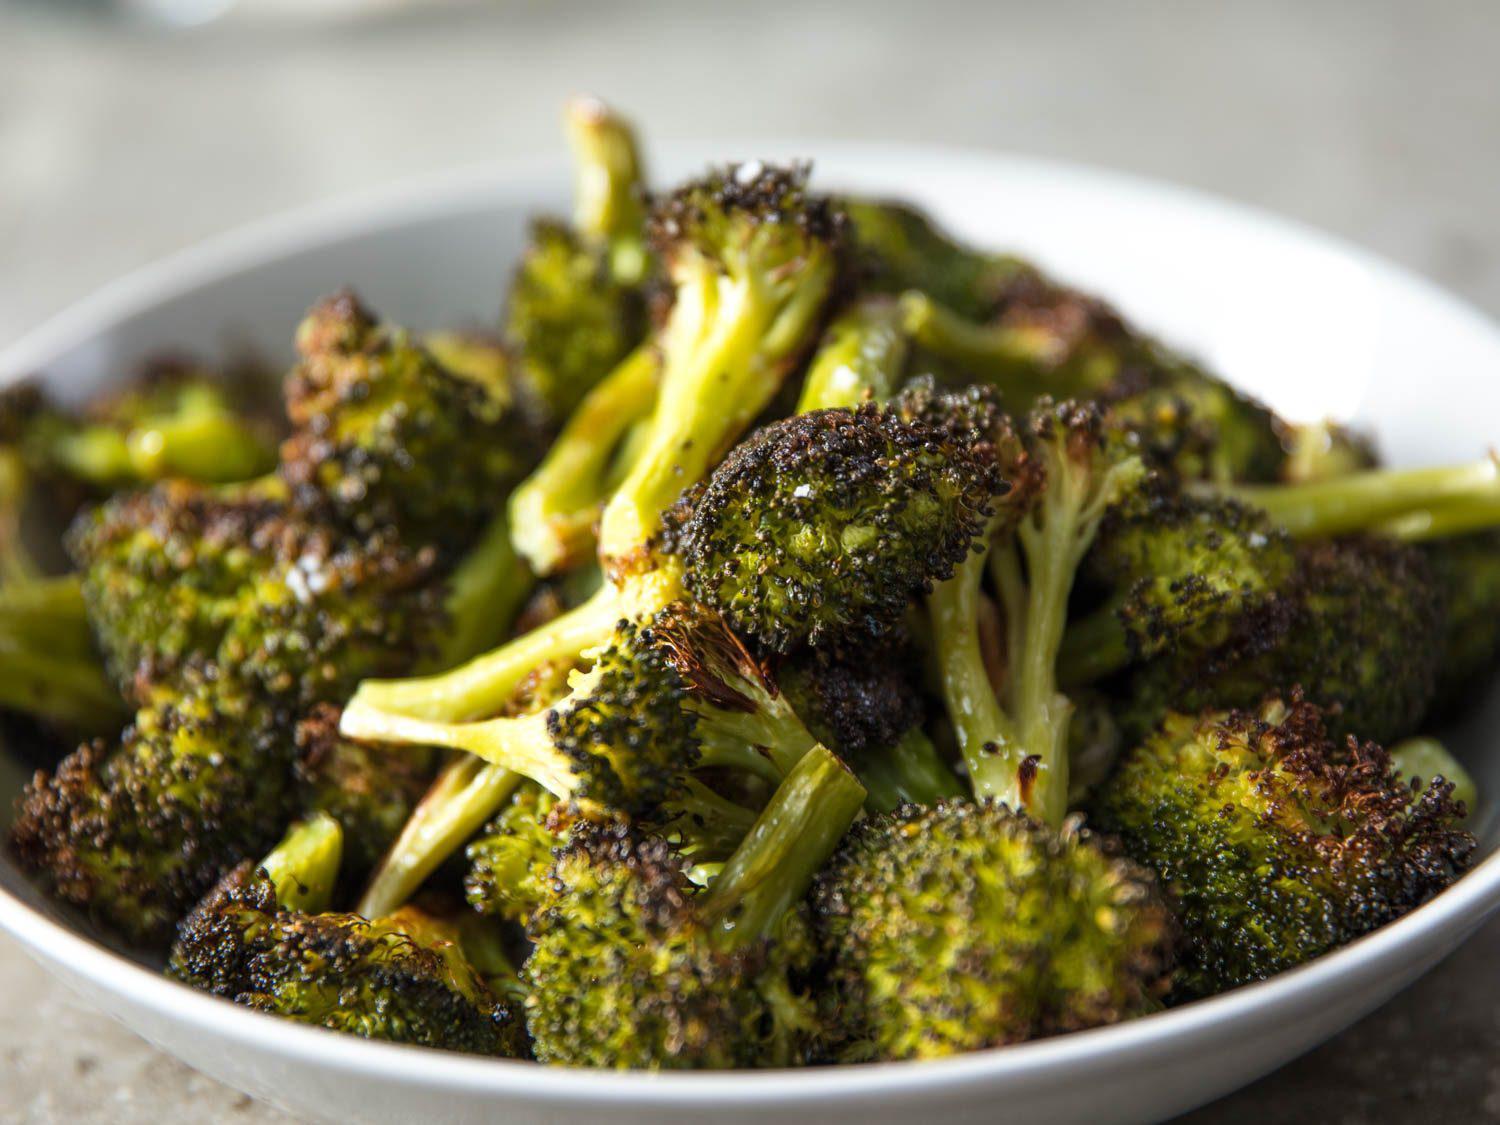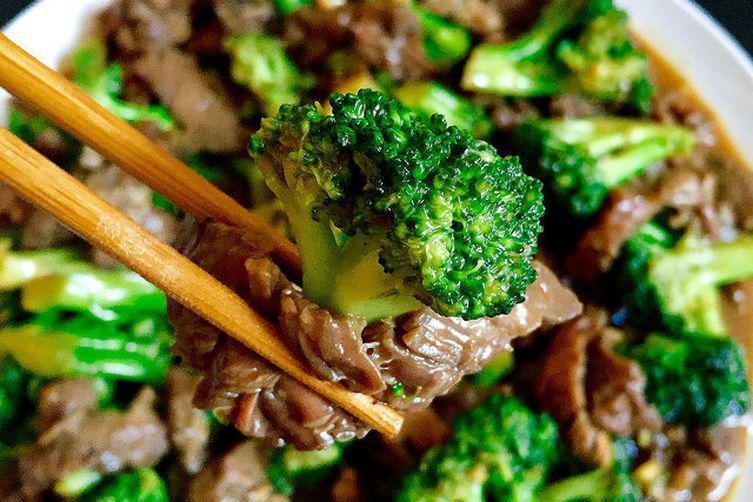The first image is the image on the left, the second image is the image on the right. Assess this claim about the two images: "Two parallel sticks are over a round bowl containing broccoli florets in one image.". Correct or not? Answer yes or no. Yes. The first image is the image on the left, the second image is the image on the right. Given the left and right images, does the statement "Everything is in white bowls." hold true? Answer yes or no. Yes. 